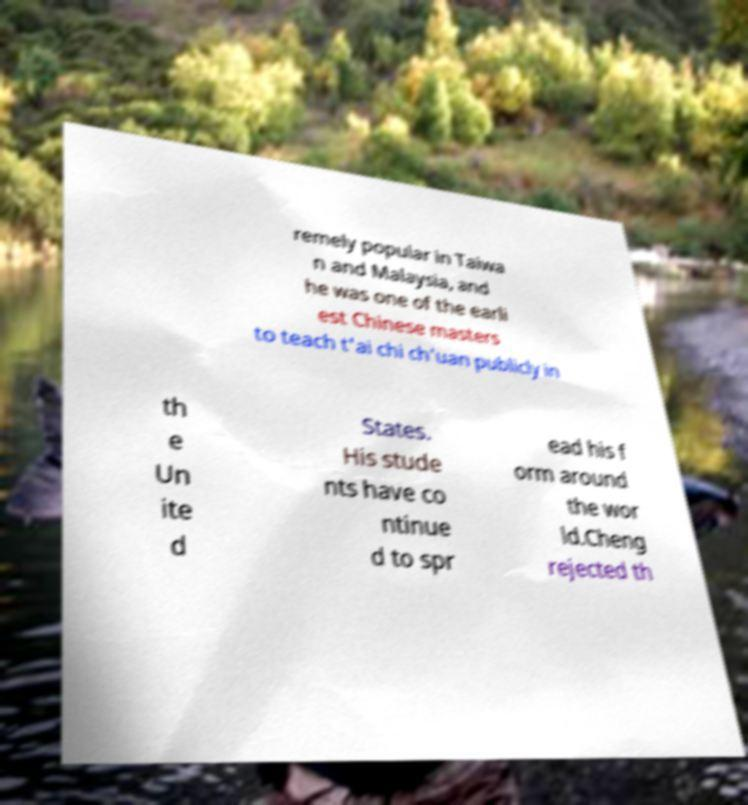Can you read and provide the text displayed in the image?This photo seems to have some interesting text. Can you extract and type it out for me? remely popular in Taiwa n and Malaysia, and he was one of the earli est Chinese masters to teach t'ai chi ch'uan publicly in th e Un ite d States. His stude nts have co ntinue d to spr ead his f orm around the wor ld.Cheng rejected th 